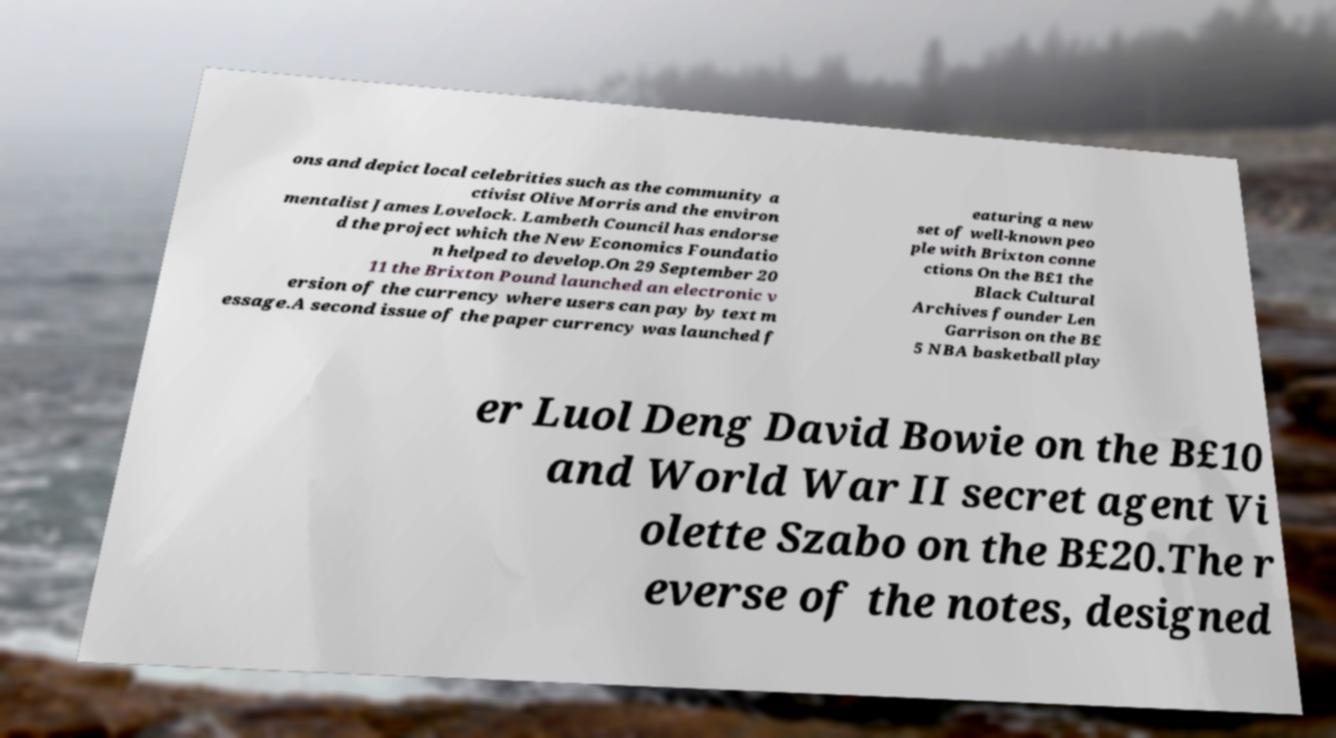What messages or text are displayed in this image? I need them in a readable, typed format. ons and depict local celebrities such as the community a ctivist Olive Morris and the environ mentalist James Lovelock. Lambeth Council has endorse d the project which the New Economics Foundatio n helped to develop.On 29 September 20 11 the Brixton Pound launched an electronic v ersion of the currency where users can pay by text m essage.A second issue of the paper currency was launched f eaturing a new set of well-known peo ple with Brixton conne ctions On the B£1 the Black Cultural Archives founder Len Garrison on the B£ 5 NBA basketball play er Luol Deng David Bowie on the B£10 and World War II secret agent Vi olette Szabo on the B£20.The r everse of the notes, designed 